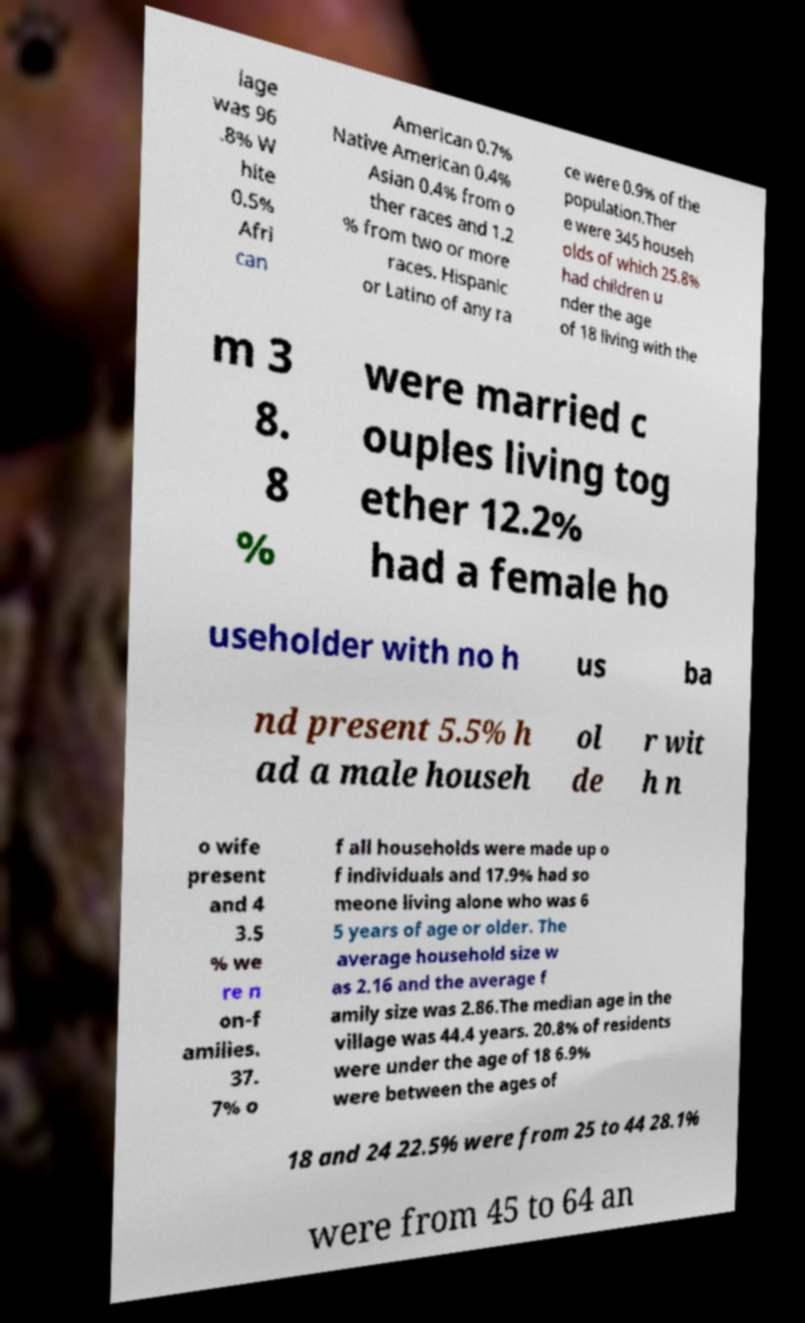Could you extract and type out the text from this image? lage was 96 .8% W hite 0.5% Afri can American 0.7% Native American 0.4% Asian 0.4% from o ther races and 1.2 % from two or more races. Hispanic or Latino of any ra ce were 0.9% of the population.Ther e were 345 househ olds of which 25.8% had children u nder the age of 18 living with the m 3 8. 8 % were married c ouples living tog ether 12.2% had a female ho useholder with no h us ba nd present 5.5% h ad a male househ ol de r wit h n o wife present and 4 3.5 % we re n on-f amilies. 37. 7% o f all households were made up o f individuals and 17.9% had so meone living alone who was 6 5 years of age or older. The average household size w as 2.16 and the average f amily size was 2.86.The median age in the village was 44.4 years. 20.8% of residents were under the age of 18 6.9% were between the ages of 18 and 24 22.5% were from 25 to 44 28.1% were from 45 to 64 an 